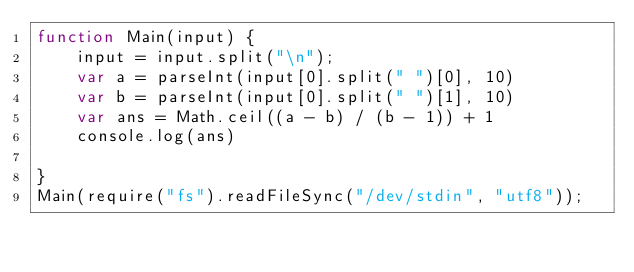Convert code to text. <code><loc_0><loc_0><loc_500><loc_500><_JavaScript_>function Main(input) {
    input = input.split("\n");
    var a = parseInt(input[0].split(" ")[0], 10)
    var b = parseInt(input[0].split(" ")[1], 10)
    var ans = Math.ceil((a - b) / (b - 1)) + 1
    console.log(ans)

}
Main(require("fs").readFileSync("/dev/stdin", "utf8"));</code> 